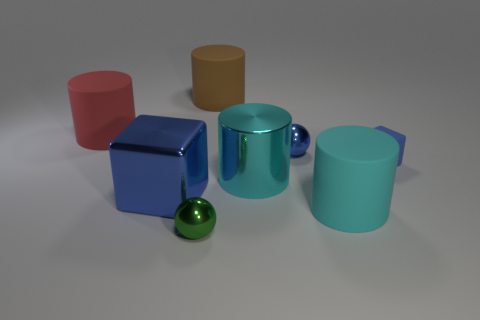Is there a rubber thing of the same size as the green metallic object? Yes, there is a small green spherical object that appears to be of similar size to the green metallic cylinder. However, without knowing the exact properties of each object, I can't confirm whether the spherical object is made of rubber. 